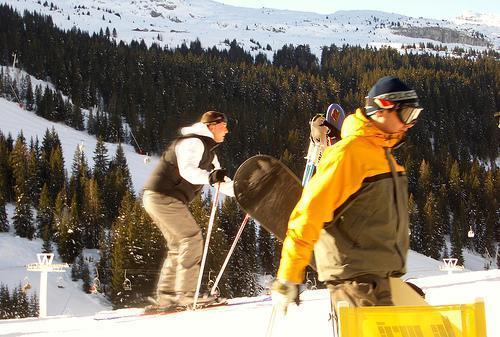How many people are depicted?
Give a very brief answer. 2. 